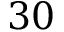<formula> <loc_0><loc_0><loc_500><loc_500>3 0</formula> 